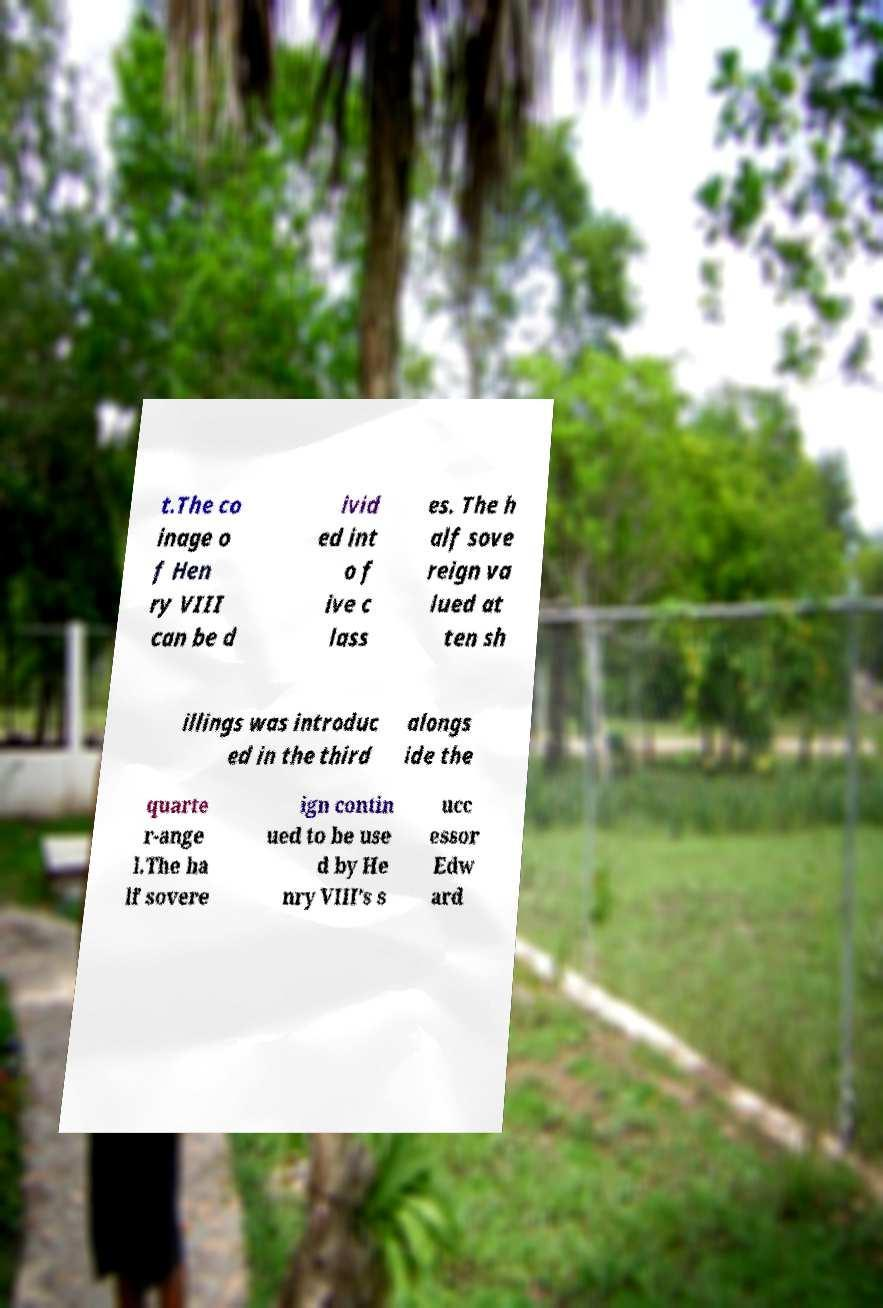Could you extract and type out the text from this image? t.The co inage o f Hen ry VIII can be d ivid ed int o f ive c lass es. The h alf sove reign va lued at ten sh illings was introduc ed in the third alongs ide the quarte r-ange l.The ha lf sovere ign contin ued to be use d by He nry VIII’s s ucc essor Edw ard 